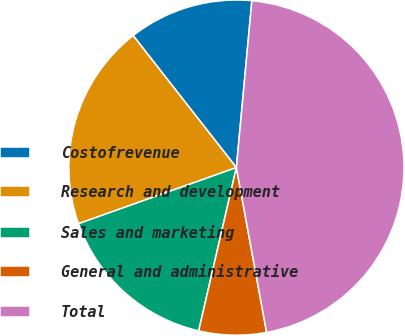Convert chart. <chart><loc_0><loc_0><loc_500><loc_500><pie_chart><fcel>Costofrevenue<fcel>Research and development<fcel>Sales and marketing<fcel>General and administrative<fcel>Total<nl><fcel>12.04%<fcel>19.87%<fcel>15.95%<fcel>6.5%<fcel>45.64%<nl></chart> 